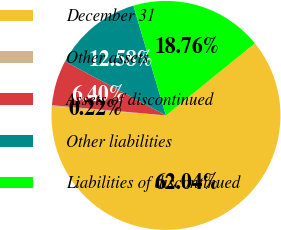Convert chart to OTSL. <chart><loc_0><loc_0><loc_500><loc_500><pie_chart><fcel>December 31<fcel>Other assets<fcel>Assets of discontinued<fcel>Other liabilities<fcel>Liabilities of discontinued<nl><fcel>62.04%<fcel>0.22%<fcel>6.4%<fcel>12.58%<fcel>18.76%<nl></chart> 